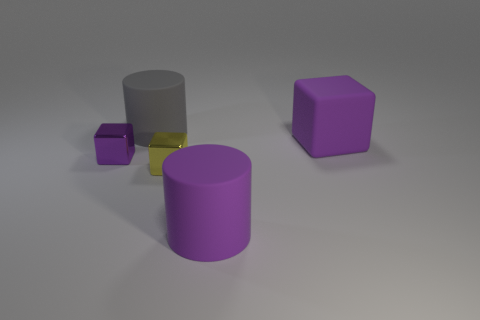What number of large objects are either gray rubber things or matte blocks?
Offer a very short reply. 2. How many rubber objects are both on the right side of the large gray matte cylinder and on the left side of the large purple rubber block?
Your response must be concise. 1. Does the large gray cylinder have the same material as the tiny thing that is to the left of the gray object?
Keep it short and to the point. No. How many brown objects are either big cylinders or matte things?
Offer a terse response. 0. Is there a yellow block that has the same size as the purple cylinder?
Provide a short and direct response. No. There is a big purple thing behind the purple cube that is to the left of the rubber object in front of the small yellow thing; what is it made of?
Your response must be concise. Rubber. Are there the same number of yellow things to the left of the tiny yellow metallic object and small yellow rubber cylinders?
Your response must be concise. Yes. Are the large cylinder that is behind the big block and the tiny thing on the right side of the gray cylinder made of the same material?
Ensure brevity in your answer.  No. What number of things are either tiny metal objects or purple matte things that are right of the large purple matte cylinder?
Your answer should be compact. 3. Is there another purple object that has the same shape as the small purple thing?
Ensure brevity in your answer.  Yes. 